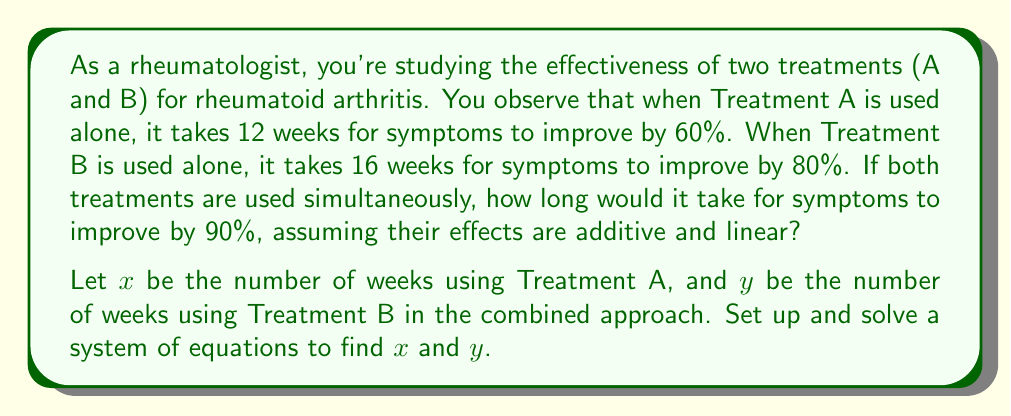Give your solution to this math problem. Let's approach this step-by-step:

1) First, we need to set up our equations based on the given information:

   For Treatment A: $\frac{60\%}{12 \text{ weeks}} = 5\%$ improvement per week
   For Treatment B: $\frac{80\%}{16 \text{ weeks}} = 5\%$ improvement per week

2) Now, let's set up our system of equations:

   $$\begin{cases}
   5x + 5y = 90 \quad \text{(90% improvement)}\\
   x + y = t \quad \text{(total time)}
   \end{cases}$$

   Where $t$ is the total time we're trying to find.

3) Simplify the first equation:
   
   $$x + y = 18$$

4) Now we have:

   $$\begin{cases}
   x + y = 18\\
   x + y = t
   \end{cases}$$

5) From this, we can directly conclude that $t = 18$.

Therefore, it would take 18 weeks for symptoms to improve by 90% when both treatments are used simultaneously.

Note: This model assumes that the treatments' effects are perfectly additive and linear, which may not be entirely realistic in a clinical setting. In practice, drug interactions and non-linear responses could complicate the outcome.
Answer: 18 weeks 